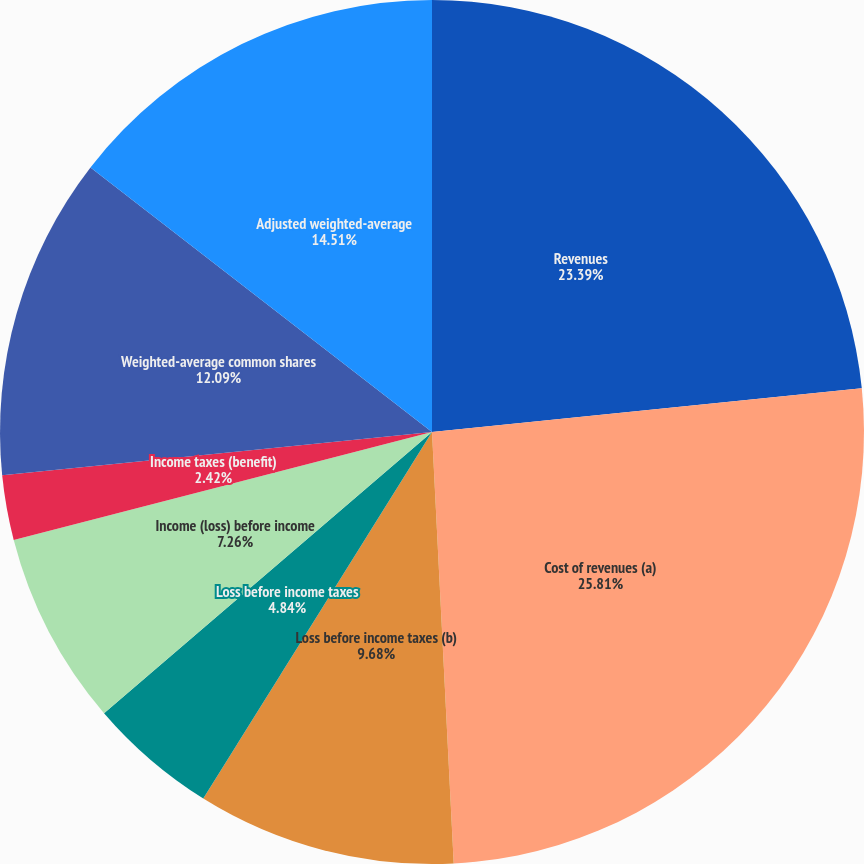Convert chart. <chart><loc_0><loc_0><loc_500><loc_500><pie_chart><fcel>Revenues<fcel>Cost of revenues (a)<fcel>Loss before income taxes (b)<fcel>Loss before income taxes<fcel>Income (loss) before income<fcel>Income taxes (benefit)<fcel>Net loss<fcel>Weighted-average common shares<fcel>Adjusted weighted-average<nl><fcel>23.39%<fcel>25.81%<fcel>9.68%<fcel>4.84%<fcel>7.26%<fcel>2.42%<fcel>0.0%<fcel>12.09%<fcel>14.51%<nl></chart> 